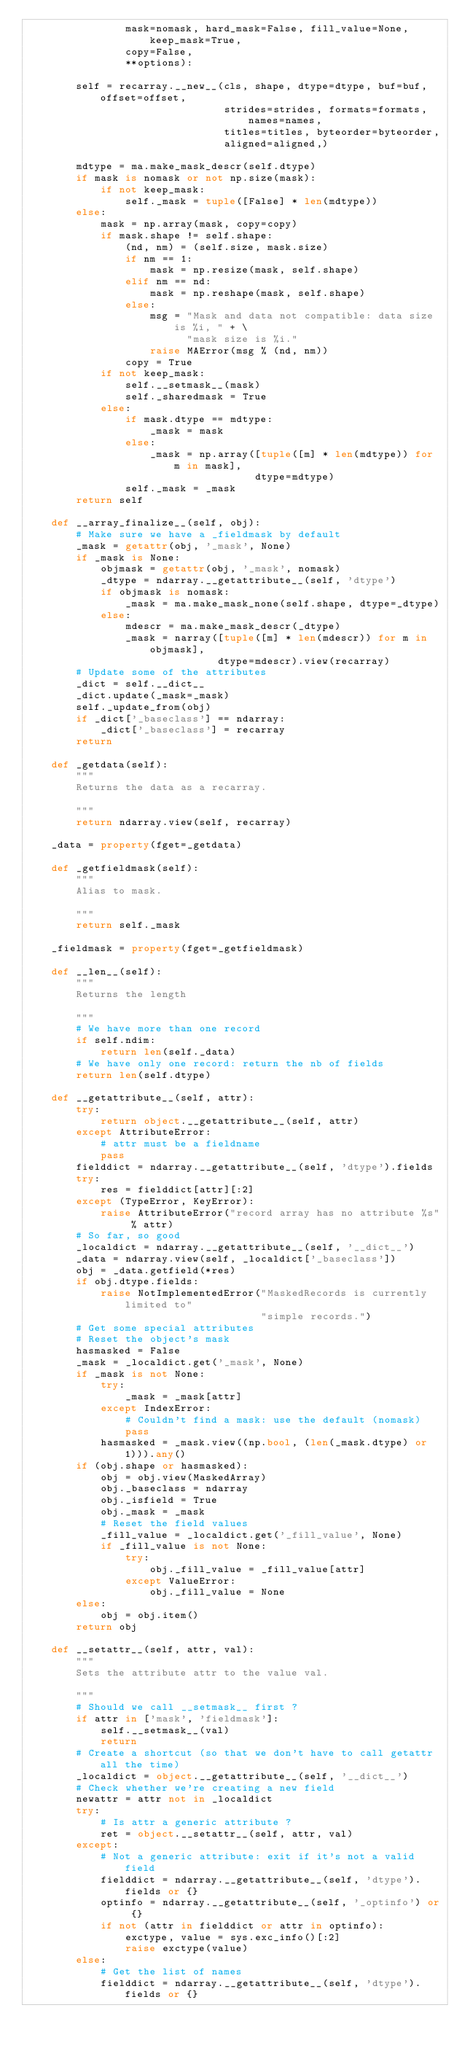Convert code to text. <code><loc_0><loc_0><loc_500><loc_500><_Python_>                mask=nomask, hard_mask=False, fill_value=None, keep_mask=True,
                copy=False,
                **options):

        self = recarray.__new__(cls, shape, dtype=dtype, buf=buf, offset=offset,
                                strides=strides, formats=formats, names=names,
                                titles=titles, byteorder=byteorder,
                                aligned=aligned,)

        mdtype = ma.make_mask_descr(self.dtype)
        if mask is nomask or not np.size(mask):
            if not keep_mask:
                self._mask = tuple([False] * len(mdtype))
        else:
            mask = np.array(mask, copy=copy)
            if mask.shape != self.shape:
                (nd, nm) = (self.size, mask.size)
                if nm == 1:
                    mask = np.resize(mask, self.shape)
                elif nm == nd:
                    mask = np.reshape(mask, self.shape)
                else:
                    msg = "Mask and data not compatible: data size is %i, " + \
                          "mask size is %i."
                    raise MAError(msg % (nd, nm))
                copy = True
            if not keep_mask:
                self.__setmask__(mask)
                self._sharedmask = True
            else:
                if mask.dtype == mdtype:
                    _mask = mask
                else:
                    _mask = np.array([tuple([m] * len(mdtype)) for m in mask],
                                     dtype=mdtype)
                self._mask = _mask
        return self

    def __array_finalize__(self, obj):
        # Make sure we have a _fieldmask by default
        _mask = getattr(obj, '_mask', None)
        if _mask is None:
            objmask = getattr(obj, '_mask', nomask)
            _dtype = ndarray.__getattribute__(self, 'dtype')
            if objmask is nomask:
                _mask = ma.make_mask_none(self.shape, dtype=_dtype)
            else:
                mdescr = ma.make_mask_descr(_dtype)
                _mask = narray([tuple([m] * len(mdescr)) for m in objmask],
                               dtype=mdescr).view(recarray)
        # Update some of the attributes
        _dict = self.__dict__
        _dict.update(_mask=_mask)
        self._update_from(obj)
        if _dict['_baseclass'] == ndarray:
            _dict['_baseclass'] = recarray
        return

    def _getdata(self):
        """
        Returns the data as a recarray.

        """
        return ndarray.view(self, recarray)

    _data = property(fget=_getdata)

    def _getfieldmask(self):
        """
        Alias to mask.

        """
        return self._mask

    _fieldmask = property(fget=_getfieldmask)

    def __len__(self):
        """
        Returns the length

        """
        # We have more than one record
        if self.ndim:
            return len(self._data)
        # We have only one record: return the nb of fields
        return len(self.dtype)

    def __getattribute__(self, attr):
        try:
            return object.__getattribute__(self, attr)
        except AttributeError:
            # attr must be a fieldname
            pass
        fielddict = ndarray.__getattribute__(self, 'dtype').fields
        try:
            res = fielddict[attr][:2]
        except (TypeError, KeyError):
            raise AttributeError("record array has no attribute %s" % attr)
        # So far, so good
        _localdict = ndarray.__getattribute__(self, '__dict__')
        _data = ndarray.view(self, _localdict['_baseclass'])
        obj = _data.getfield(*res)
        if obj.dtype.fields:
            raise NotImplementedError("MaskedRecords is currently limited to"
                                      "simple records.")
        # Get some special attributes
        # Reset the object's mask
        hasmasked = False
        _mask = _localdict.get('_mask', None)
        if _mask is not None:
            try:
                _mask = _mask[attr]
            except IndexError:
                # Couldn't find a mask: use the default (nomask)
                pass
            hasmasked = _mask.view((np.bool, (len(_mask.dtype) or 1))).any()
        if (obj.shape or hasmasked):
            obj = obj.view(MaskedArray)
            obj._baseclass = ndarray
            obj._isfield = True
            obj._mask = _mask
            # Reset the field values
            _fill_value = _localdict.get('_fill_value', None)
            if _fill_value is not None:
                try:
                    obj._fill_value = _fill_value[attr]
                except ValueError:
                    obj._fill_value = None
        else:
            obj = obj.item()
        return obj

    def __setattr__(self, attr, val):
        """
        Sets the attribute attr to the value val.

        """
        # Should we call __setmask__ first ?
        if attr in ['mask', 'fieldmask']:
            self.__setmask__(val)
            return
        # Create a shortcut (so that we don't have to call getattr all the time)
        _localdict = object.__getattribute__(self, '__dict__')
        # Check whether we're creating a new field
        newattr = attr not in _localdict
        try:
            # Is attr a generic attribute ?
            ret = object.__setattr__(self, attr, val)
        except:
            # Not a generic attribute: exit if it's not a valid field
            fielddict = ndarray.__getattribute__(self, 'dtype').fields or {}
            optinfo = ndarray.__getattribute__(self, '_optinfo') or {}
            if not (attr in fielddict or attr in optinfo):
                exctype, value = sys.exc_info()[:2]
                raise exctype(value)
        else:
            # Get the list of names
            fielddict = ndarray.__getattribute__(self, 'dtype').fields or {}</code> 